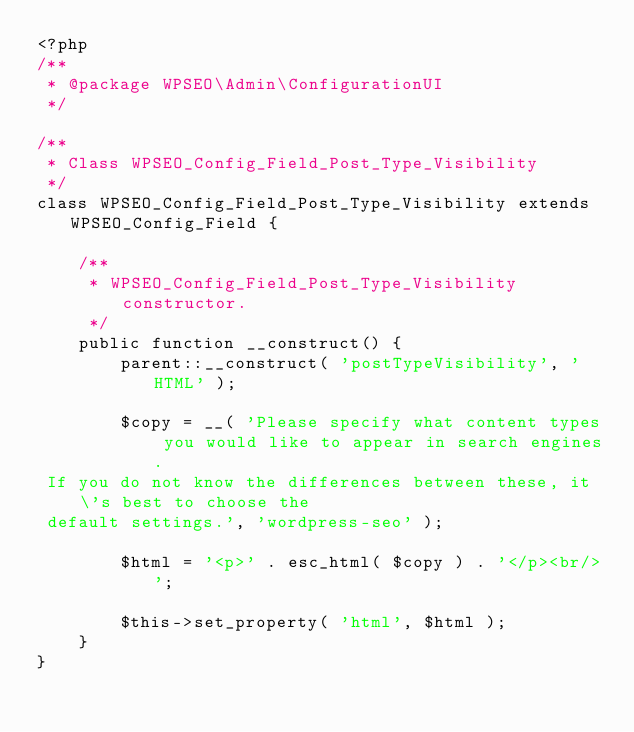Convert code to text. <code><loc_0><loc_0><loc_500><loc_500><_PHP_><?php
/**
 * @package WPSEO\Admin\ConfigurationUI
 */

/**
 * Class WPSEO_Config_Field_Post_Type_Visibility
 */
class WPSEO_Config_Field_Post_Type_Visibility extends WPSEO_Config_Field {

	/**
	 * WPSEO_Config_Field_Post_Type_Visibility constructor.
	 */
	public function __construct() {
		parent::__construct( 'postTypeVisibility', 'HTML' );

		$copy = __( 'Please specify what content types you would like to appear in search engines.
 If you do not know the differences between these, it\'s best to choose the
 default settings.', 'wordpress-seo' );

		$html = '<p>' . esc_html( $copy ) . '</p><br/>';

		$this->set_property( 'html', $html );
	}
}
</code> 